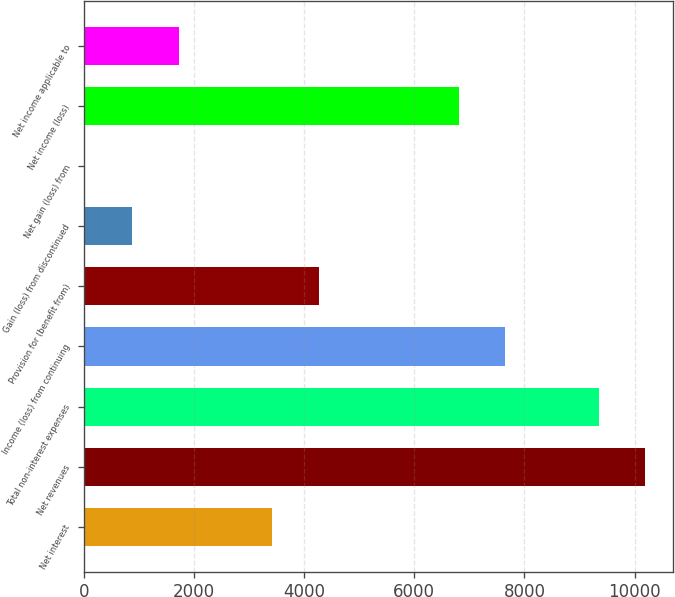Convert chart to OTSL. <chart><loc_0><loc_0><loc_500><loc_500><bar_chart><fcel>Net interest<fcel>Net revenues<fcel>Total non-interest expenses<fcel>Income (loss) from continuing<fcel>Provision for (benefit from)<fcel>Gain (loss) from discontinued<fcel>Net gain (loss) from<fcel>Net income (loss)<fcel>Net income applicable to<nl><fcel>3417.8<fcel>10195.4<fcel>9348.2<fcel>7653.8<fcel>4265<fcel>876.2<fcel>29<fcel>6806.6<fcel>1723.4<nl></chart> 